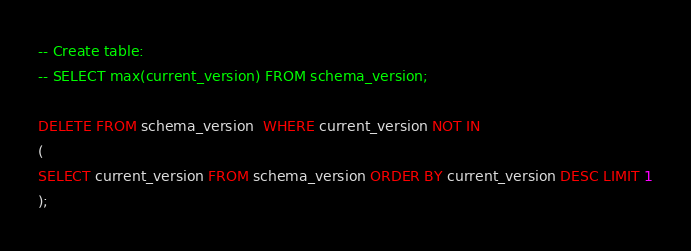Convert code to text. <code><loc_0><loc_0><loc_500><loc_500><_SQL_>
-- Create table:
-- SELECT max(current_version) FROM schema_version;

DELETE FROM schema_version  WHERE current_version NOT IN
(
SELECT current_version FROM schema_version ORDER BY current_version DESC LIMIT 1
);
</code> 